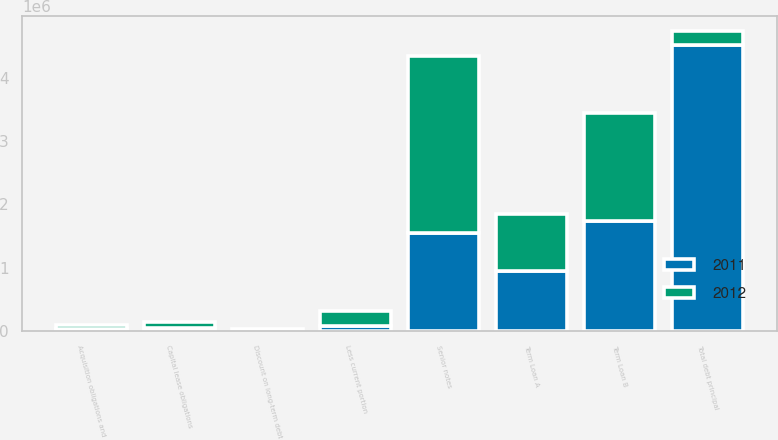<chart> <loc_0><loc_0><loc_500><loc_500><stacked_bar_chart><ecel><fcel>Term Loan A<fcel>Term Loan B<fcel>Senior notes<fcel>Acquisition obligations and<fcel>Capital lease obligations<fcel>Total debt principal<fcel>Discount on long-term debt<fcel>Less current portion<nl><fcel>2012<fcel>900000<fcel>1.715e+06<fcel>2.8e+06<fcel>64276<fcel>96594<fcel>227791<fcel>21545<fcel>227791<nl><fcel>2011<fcel>950000<fcel>1.7325e+06<fcel>1.55e+06<fcel>37447<fcel>43364<fcel>4.51281e+06<fcel>7842<fcel>87345<nl></chart> 